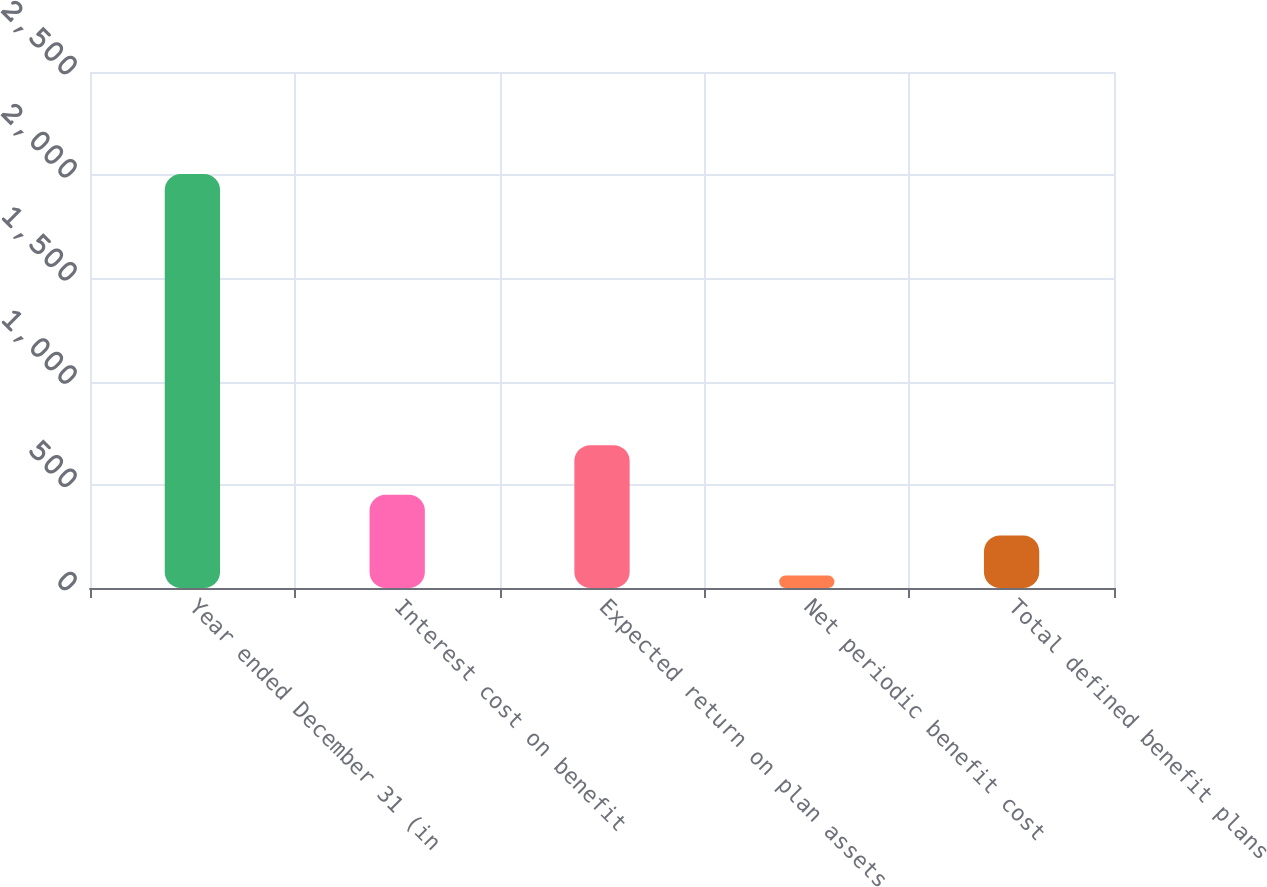Convert chart to OTSL. <chart><loc_0><loc_0><loc_500><loc_500><bar_chart><fcel>Year ended December 31 (in<fcel>Interest cost on benefit<fcel>Expected return on plan assets<fcel>Net periodic benefit cost<fcel>Total defined benefit plans<nl><fcel>2006<fcel>452<fcel>692<fcel>60<fcel>254.6<nl></chart> 